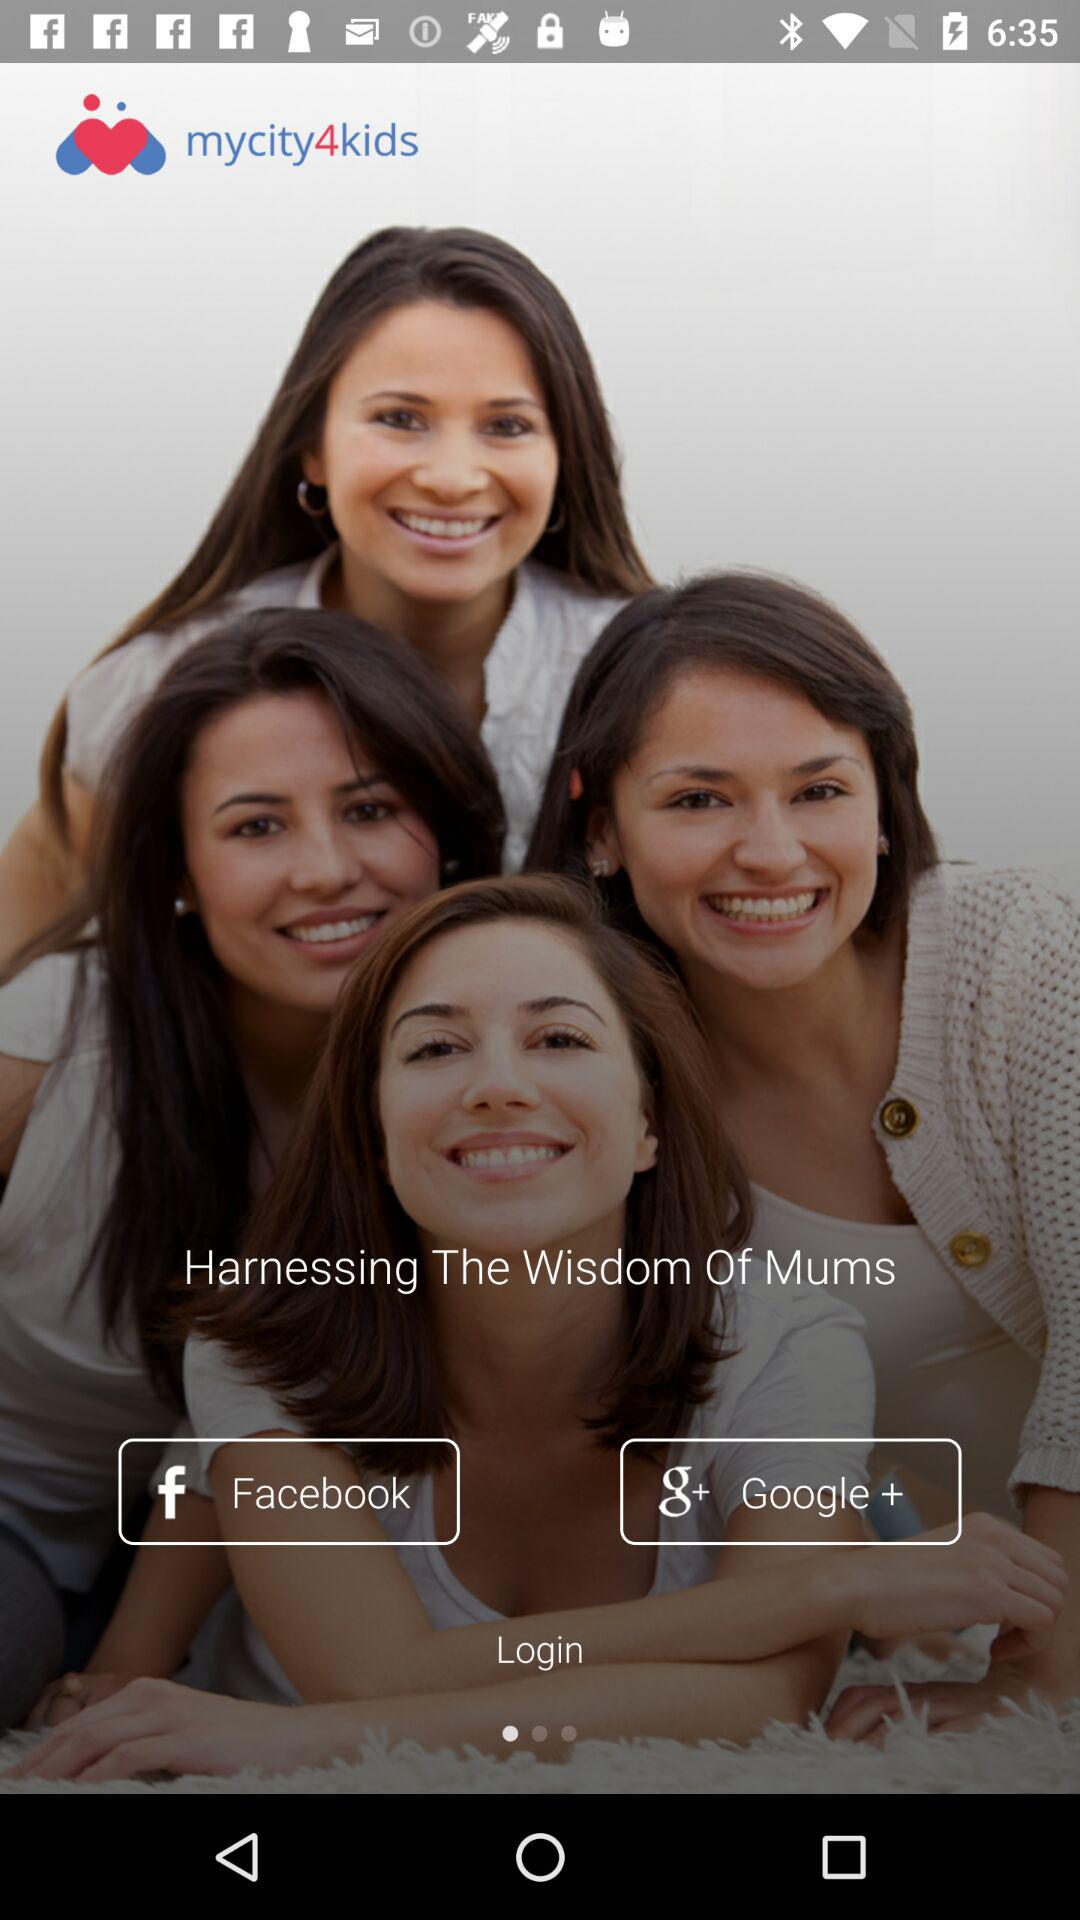Which are the different login options?
Answer the question using a single word or phrase. The different login options are "Facebook" and "Google +" 